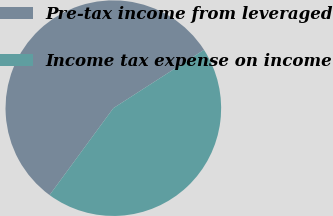<chart> <loc_0><loc_0><loc_500><loc_500><pie_chart><fcel>Pre-tax income from leveraged<fcel>Income tax expense on income<nl><fcel>55.83%<fcel>44.17%<nl></chart> 